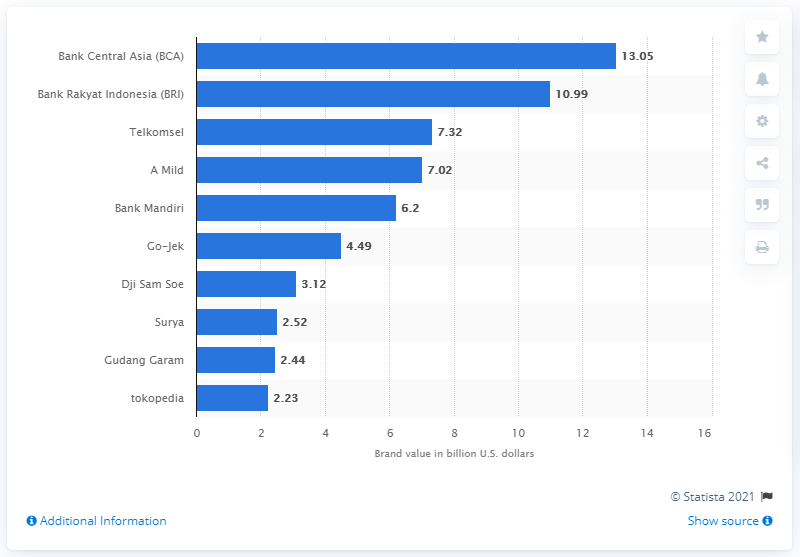What was Bank Central Asia's brand value in dollars in 2019? In 2019, Bank Central Asia (BCA) had a brand value of 13.05 billion U.S. dollars. This value signifies BCA's strong financial position and recognition in the market, making it one of the valuable brands in Indonesia. 